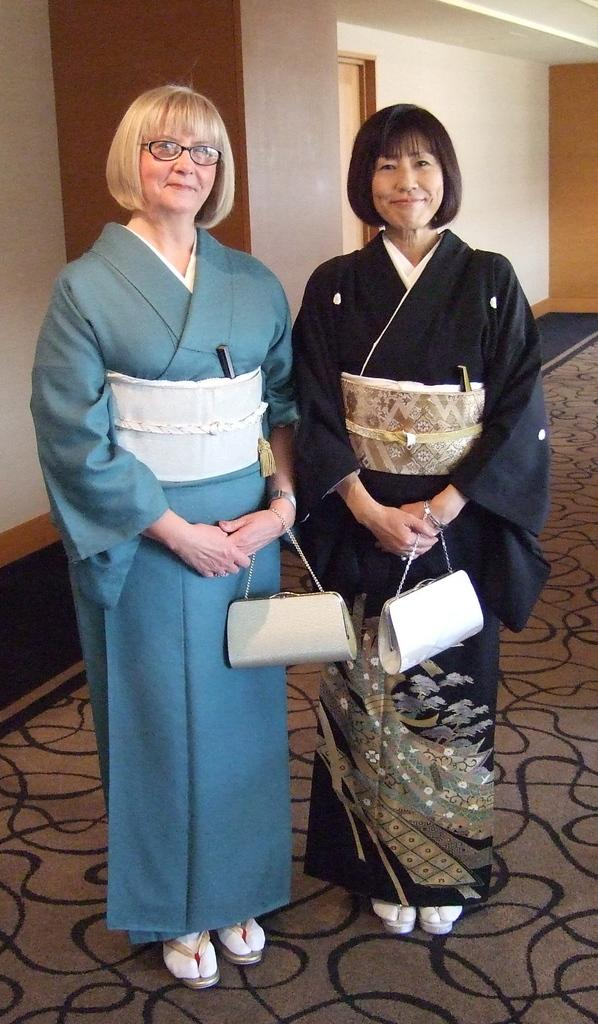How many women are in the image? There are two women in the image. What are the women doing in the image? The women are standing and smiling. What items do the women have with them? The women have handbags. What can be seen in the background of the image? There is a wall and a door in the background of the image. What type of feast is being prepared in the image? There is no feast being prepared in the image; it only shows two women standing and smiling. Can you see any shelves in the image? There are no shelves visible in the image. 